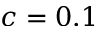Convert formula to latex. <formula><loc_0><loc_0><loc_500><loc_500>c = 0 . 1</formula> 